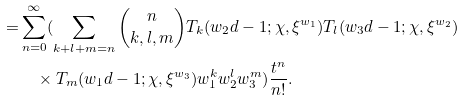<formula> <loc_0><loc_0><loc_500><loc_500>= & \sum _ { n = 0 } ^ { \infty } ( \sum _ { k + l + m = n } \binom { n } { k , l , m } T _ { k } ( w _ { 2 } d - 1 ; \chi , \xi ^ { w _ { 1 } } ) T _ { l } ( w _ { 3 } d - 1 ; \chi , \xi ^ { w _ { 2 } } ) \\ & \quad \times T _ { m } ( w _ { 1 } d - 1 ; \chi , \xi ^ { w _ { 3 } } ) w _ { 1 } ^ { k } w _ { 2 } ^ { l } w _ { 3 } ^ { m } ) \frac { t ^ { n } } { n ! } . \quad \\ & \\</formula> 